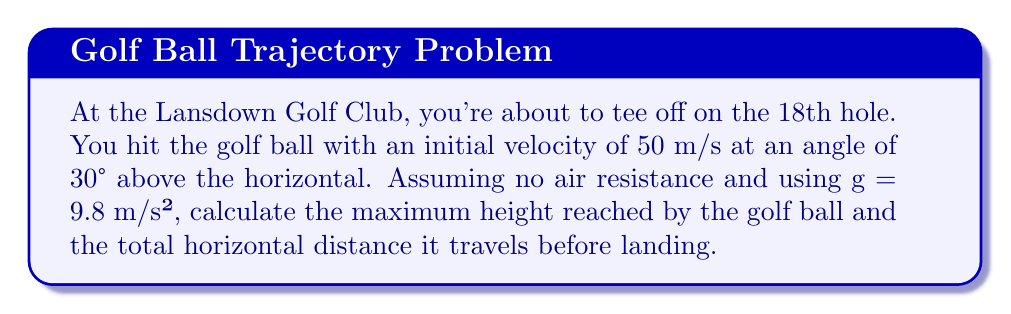Teach me how to tackle this problem. Let's approach this step-by-step using vector components:

1) First, let's break down the initial velocity into its horizontal and vertical components:
   $$v_x = v \cos\theta = 50 \cos(30°) = 43.3 \text{ m/s}$$
   $$v_y = v \sin\theta = 50 \sin(30°) = 25 \text{ m/s}$$

2) The time to reach maximum height is when the vertical velocity becomes zero:
   $$0 = v_y - gt$$
   $$t = \frac{v_y}{g} = \frac{25}{9.8} = 2.55 \text{ s}$$

3) The maximum height can be calculated using:
   $$h = v_y t - \frac{1}{2}gt^2$$
   $$h = 25(2.55) - \frac{1}{2}(9.8)(2.55)^2 = 31.9 \text{ m}$$

4) The total time of flight is twice the time to reach maximum height:
   $$t_{total} = 2(2.55) = 5.1 \text{ s}$$

5) The horizontal distance traveled is:
   $$d = v_x t_{total} = 43.3(5.1) = 220.8 \text{ m}$$

Therefore, the golf ball reaches a maximum height of 31.9 m and travels a total horizontal distance of 220.8 m.
Answer: Maximum height: 31.9 m; Horizontal distance: 220.8 m 